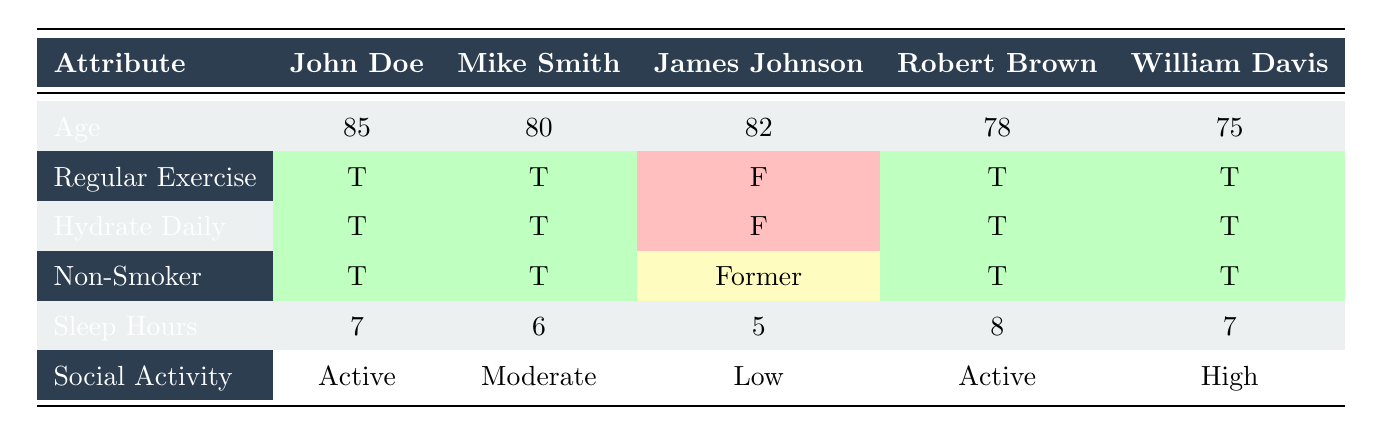What is the age of Robert Brown? From the table, the age value listed under Robert Brown is 78.
Answer: 78 How many athletes have a regular exercise habit? Referring to the table, four athletes (John Doe, Mike Smith, Robert Brown, and William Davis) have a 'T' (true) in the Regular Exercise row.
Answer: 4 Is James Johnson a non-smoker? The table indicates that James Johnson is a former smoker, which does not classify him as a non-smoker.
Answer: No What is the average number of sleep hours for the athletes? The sleep hours for the athletes are 7, 6, 5, 8, and 7. Summing these: 7 + 6 + 5 + 8 + 7 = 33. There are 5 athletes, so the average is 33/5 = 6.6.
Answer: 6.6 Which athlete has the highest social activity level? Comparing the social activity levels, William Davis has a 'High' status, which is greater than the others (Active, Moderate, and Low) in the table.
Answer: William Davis What is the diet type for Mike Smith? According to the table, the diet type mentioned for Mike Smith is 'vegetarian.'
Answer: Vegetarian How many athletes hydrate daily? In the table, the hydration status shows four athletes (John Doe, Mike Smith, Robert Brown, and William Davis) with 'T' (true) in the Hydrate Daily row.
Answer: 4 What is the difference in age between the oldest and youngest athlete? The oldest athlete is John Doe at 85 years old, and the youngest is William Davis at 75 years old. The difference is 85 - 75 = 10 years.
Answer: 10 Which athlete has the least amount of sleep hours? By examining the sleep hours recorded, James Johnson has 5 hours, which is the lowest compared to the others (7, 6, 8, and 7).
Answer: James Johnson Is there an athlete who consumes alcohol frequently? According to the table, James Johnson has an alcohol consumption status of 'frequent.'
Answer: Yes 